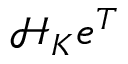<formula> <loc_0><loc_0><loc_500><loc_500>\mathcal { H } _ { K } e ^ { T }</formula> 